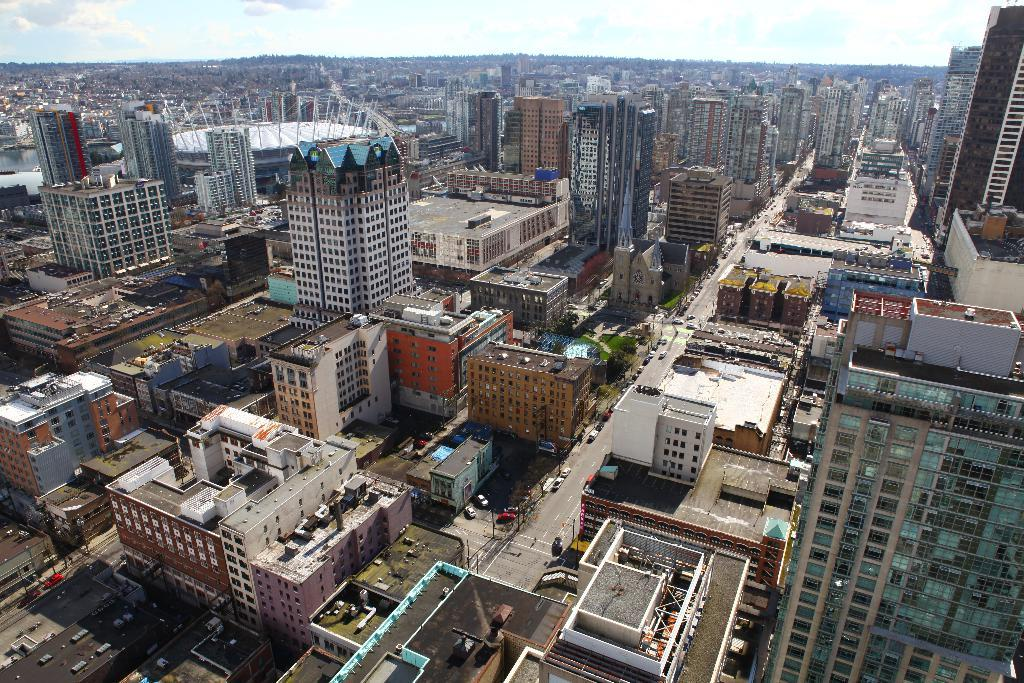What type of structures can be seen in the image? There are buildings in the image. What is happening on the road in the image? There are vehicles on the road in the image. What is the condition of the sky in the image? The sky is cloudy in the image. How many cats are sitting on the roof of the building in the image? There are no cats present in the image; it only features buildings, vehicles, and a cloudy sky. 